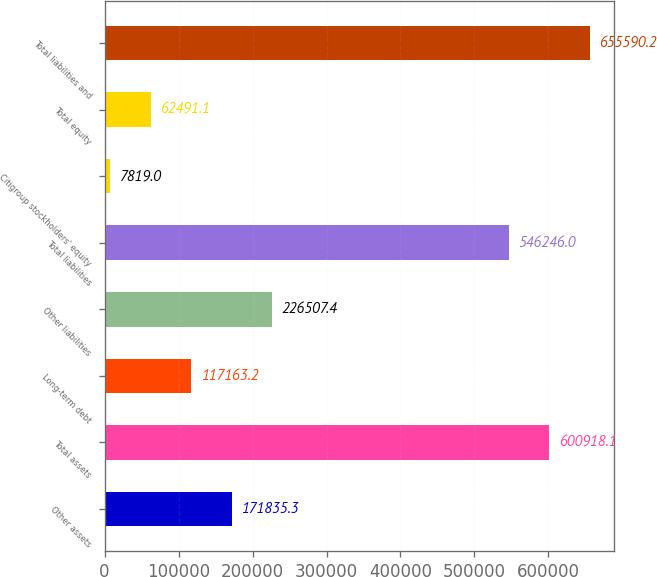Convert chart. <chart><loc_0><loc_0><loc_500><loc_500><bar_chart><fcel>Other assets<fcel>Total assets<fcel>Long-term debt<fcel>Other liabilities<fcel>Total liabilities<fcel>Citigroup stockholders' equity<fcel>Total equity<fcel>Total liabilities and<nl><fcel>171835<fcel>600918<fcel>117163<fcel>226507<fcel>546246<fcel>7819<fcel>62491.1<fcel>655590<nl></chart> 